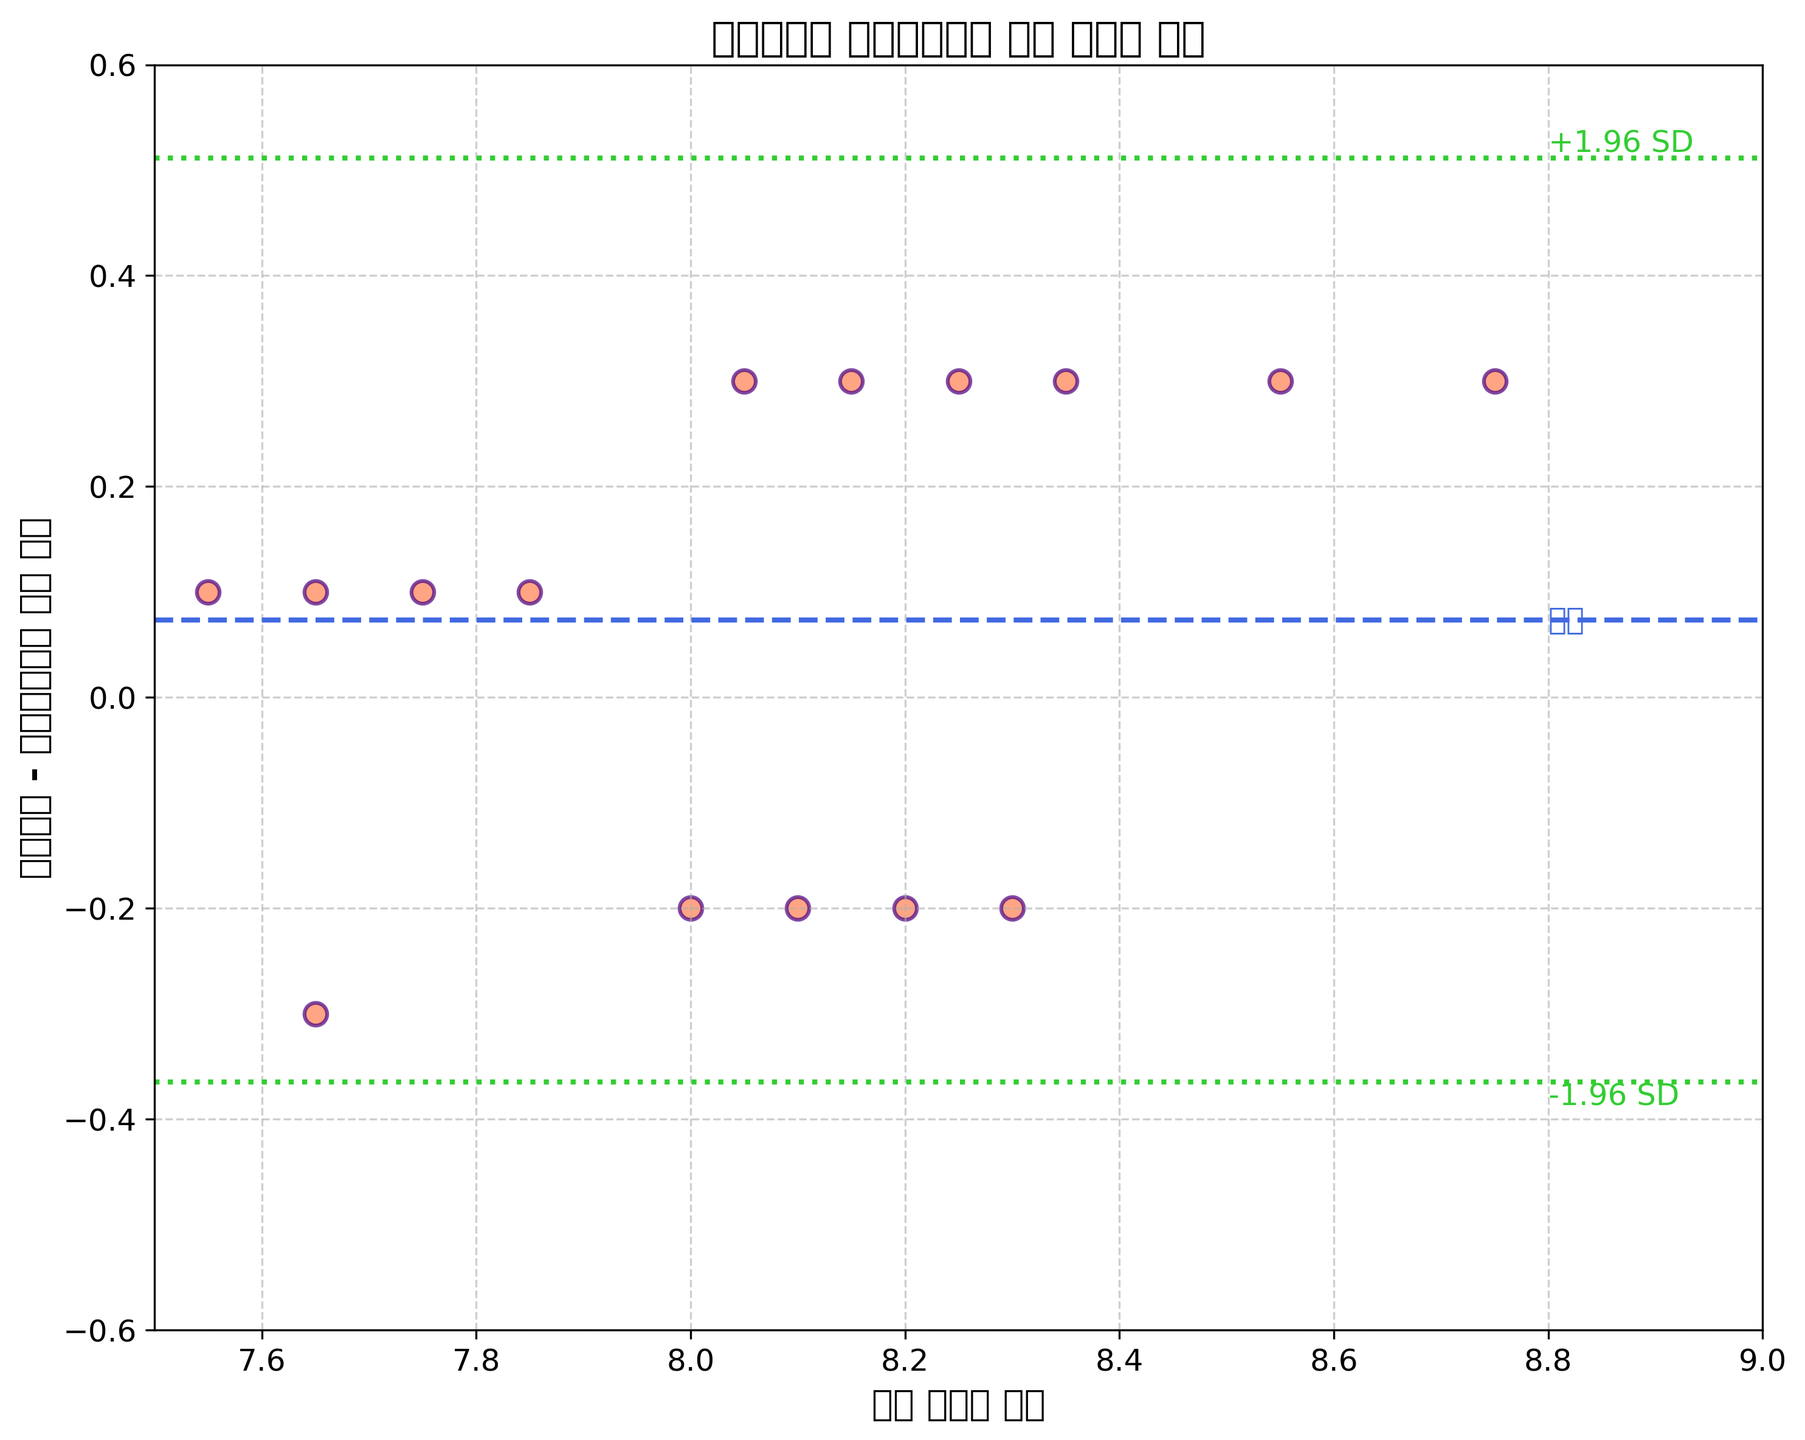What does the title of the plot say? The title is on top of the plot and summarizes the content being displayed. It mentions the comparison of customer satisfaction ratings between Korean Air and Asiana Airlines.
Answer: 대한항공과 아시아나항공 고객 만족도 비교 What do the x-axis and y-axis labels represent? The x-axis label represents the average satisfaction scores between Korean Air and Asiana Airlines, while the y-axis label shows the difference in their satisfaction scores.
Answer: 평균 만족도 점수, 대한항공 - 아시아나항공 점수 차이 How many data points are there in the plot? The number of data points is equal to the number of points shown on the scatter plot. By counting each point, we find there are 15 data points.
Answer: 15 In which range do the differences in satisfaction ratings (y-axis) lie? By looking at the y-axis, the lowest difference is around -0.3 and the highest is around 0.3. This can be confirmed by observing that all points fall between -0.3 and 0.3.
Answer: -0.3 to 0.3 What does the dashed blue line in the plot indicate? The dashed blue line represents the mean of the differences in satisfaction scores between Korean Air and Asiana Airlines. This is a baseline for comparison.
Answer: 평균 차이 What do the dotted green lines in the plot represent? The dotted green lines represent the limits of agreement, calculated as the mean difference ± 1.96 times the standard deviation of the differences. They show the range within which most differences lie.
Answer: ±1.96 SD Which data point shows the largest positive difference in satisfaction ratings? By looking at the y-axis values, the point at which the difference is 0.3 and the average satisfaction score is the highest indicates the maximum positive difference. This point corresponds to Korean Air's rating of 8.9 and Asiana Airlines' rating of 8.6.
Answer: 8.9, 8.6 Is there a trend where higher satisfaction averages correspond to larger differences? By observing the spread of data points, it appears that most of the larger differences tend to occur at higher satisfaction averages. However, a more thorough statistical analysis would confirm this trend.
Answer: Yes Do the differences in satisfaction ratings appear to be consistently positive or negative? By observing the plot, we notice that the differences fluctuate between positive and negative and are roughly balanced around the mean. This indicates there is no strong bias in one direction.
Answer: No How close are most differences in satisfaction ratings to the mean difference? Most differences lie within the range of the mean difference ± 1.96 standard deviations (between the two green dotted lines), suggesting that the differences are mostly within expected variability.
Answer: Close 